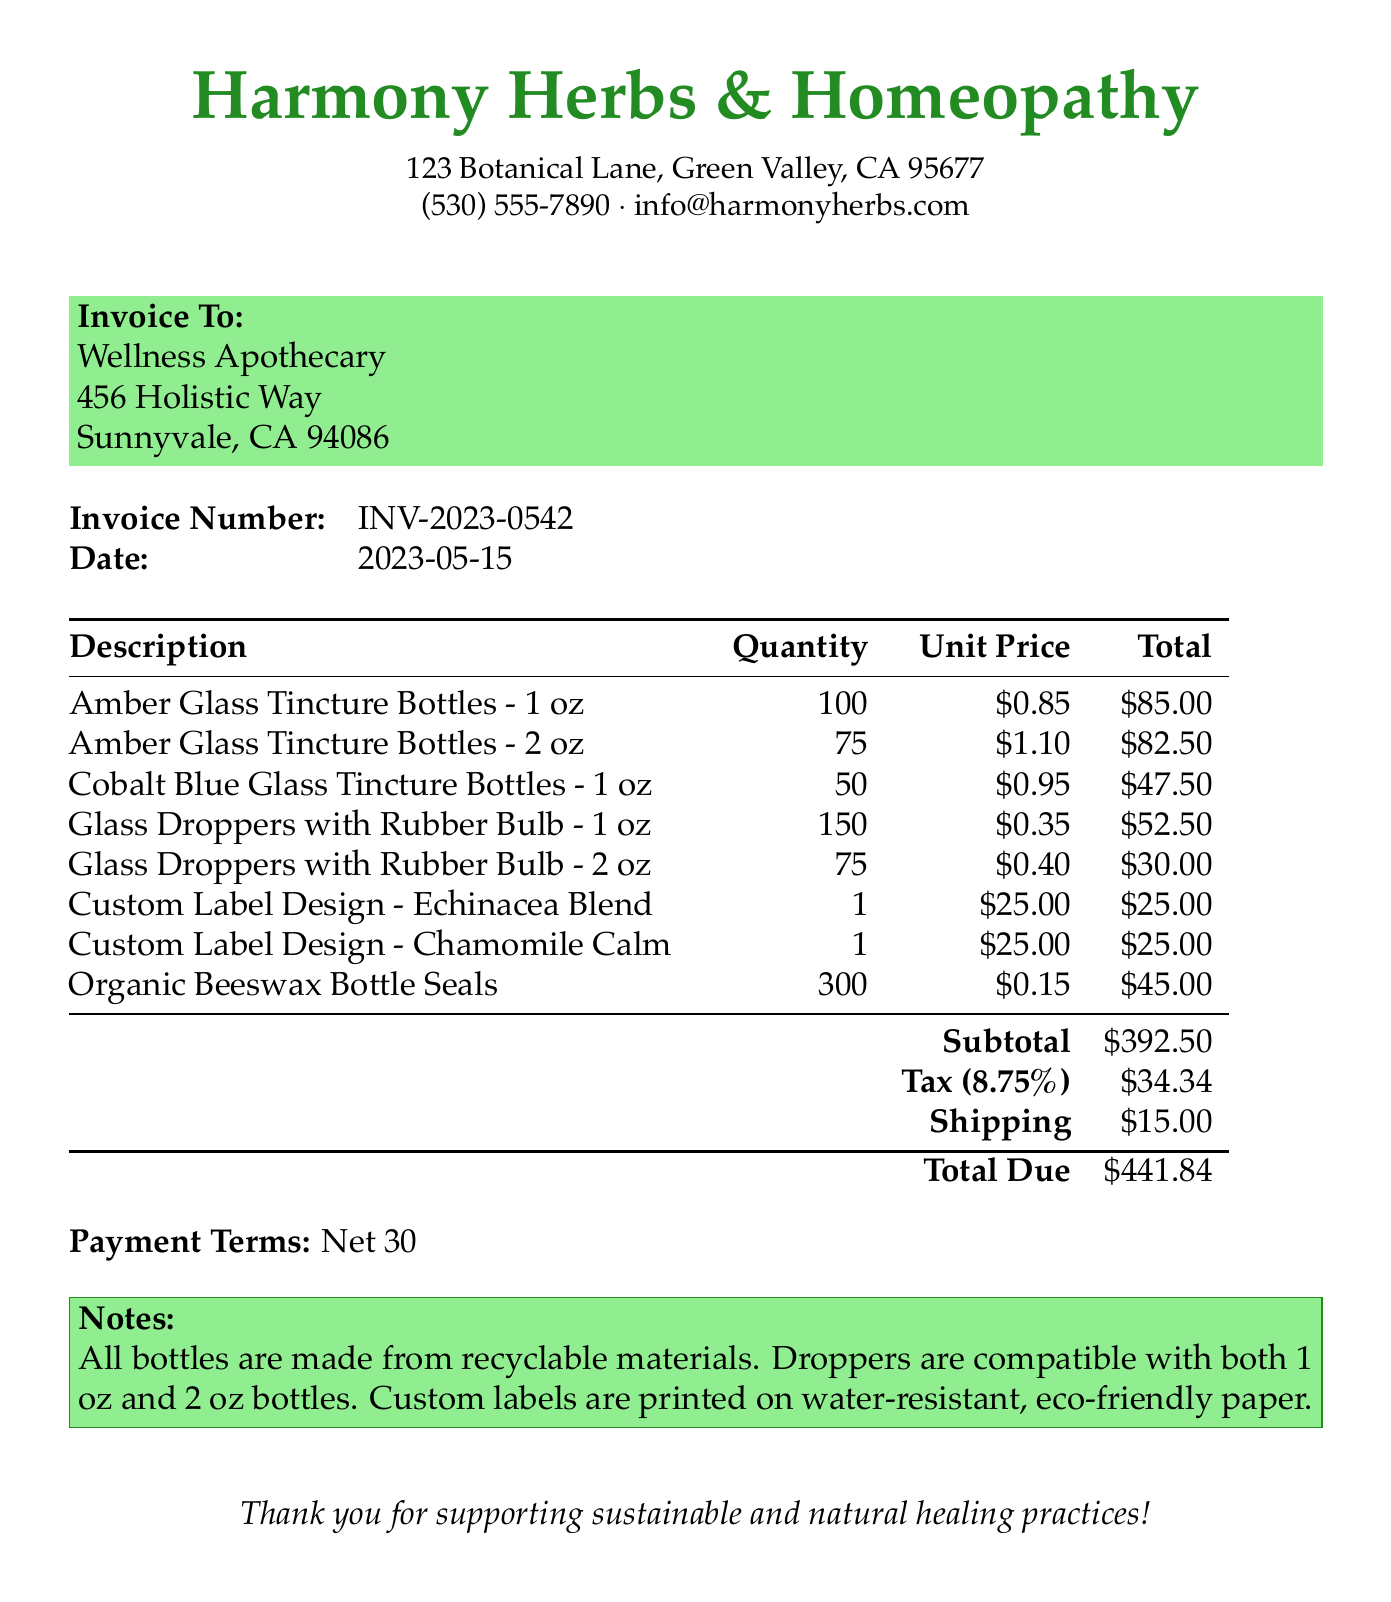What is the invoice number? The invoice number is a unique identifier for this transaction, found in the document.
Answer: INV-2023-0542 Who is the customer? The customer name appears at the top of the invoice under "Invoice To."
Answer: Wellness Apothecary What is the subtotal amount? The subtotal is the total of all item costs listed in the document, before tax and shipping.
Answer: $392.50 How many Amber Glass Tincture Bottles - 2 oz were ordered? The quantity of the specific item is listed next to its description in the document.
Answer: 75 What is the tax rate applied? The tax rate is specified in the document as a percentage.
Answer: 8.75% What items are compatible with the droppers? The document notes compatibility of certain products, indicating more than one option.
Answer: 1 oz and 2 oz bottles What materials are the bottles made from? The document includes notes about the materials used for the bottles.
Answer: Recyclable materials When is the payment due? The payment terms offer a specific timeline for settlement, which is noted in the document.
Answer: Net 30 